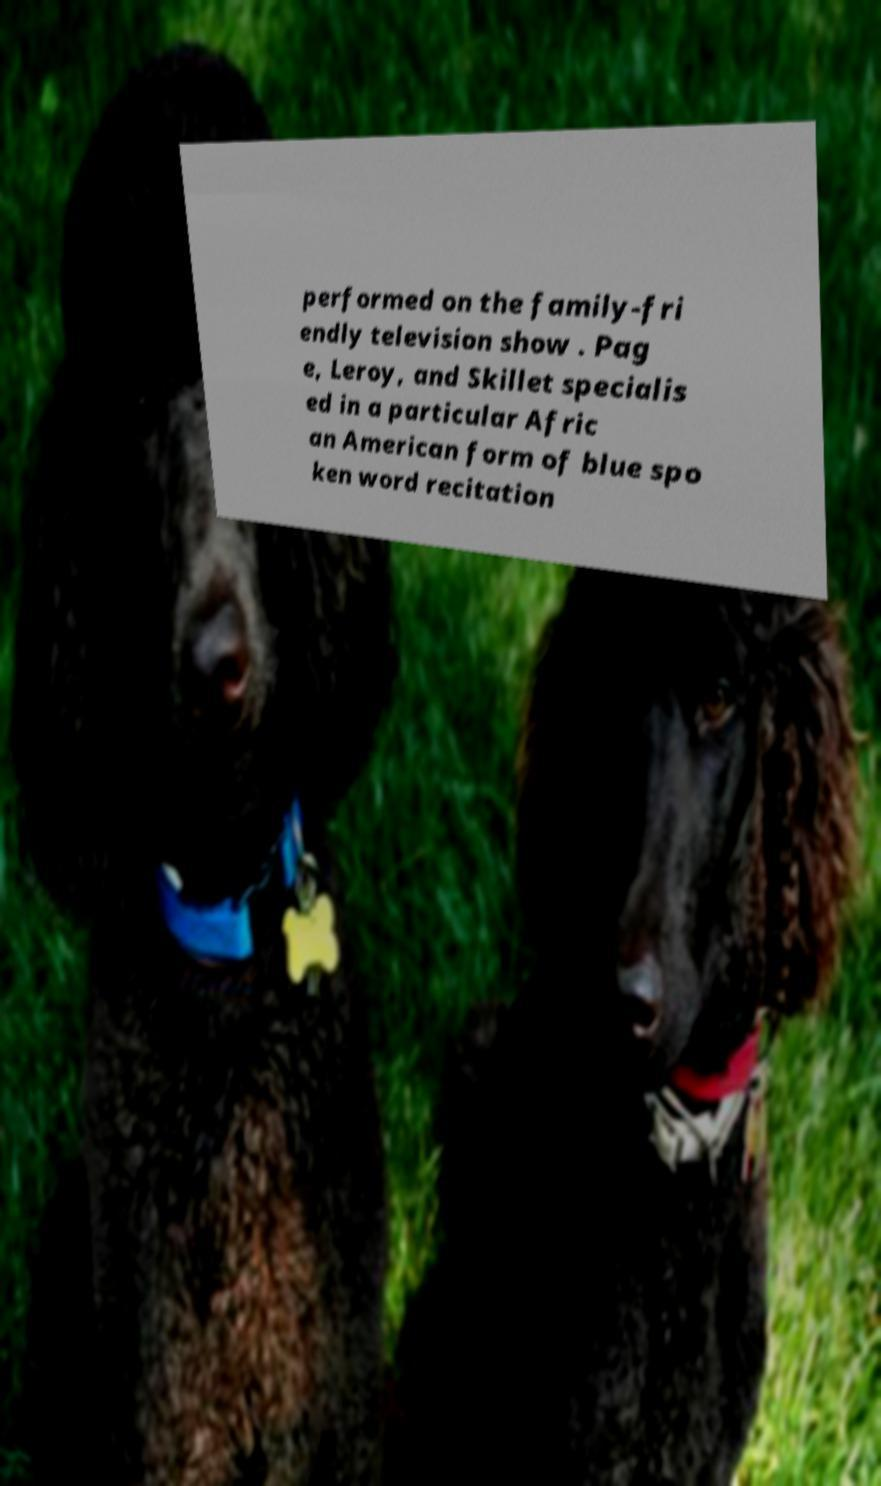Can you read and provide the text displayed in the image?This photo seems to have some interesting text. Can you extract and type it out for me? performed on the family-fri endly television show . Pag e, Leroy, and Skillet specialis ed in a particular Afric an American form of blue spo ken word recitation 